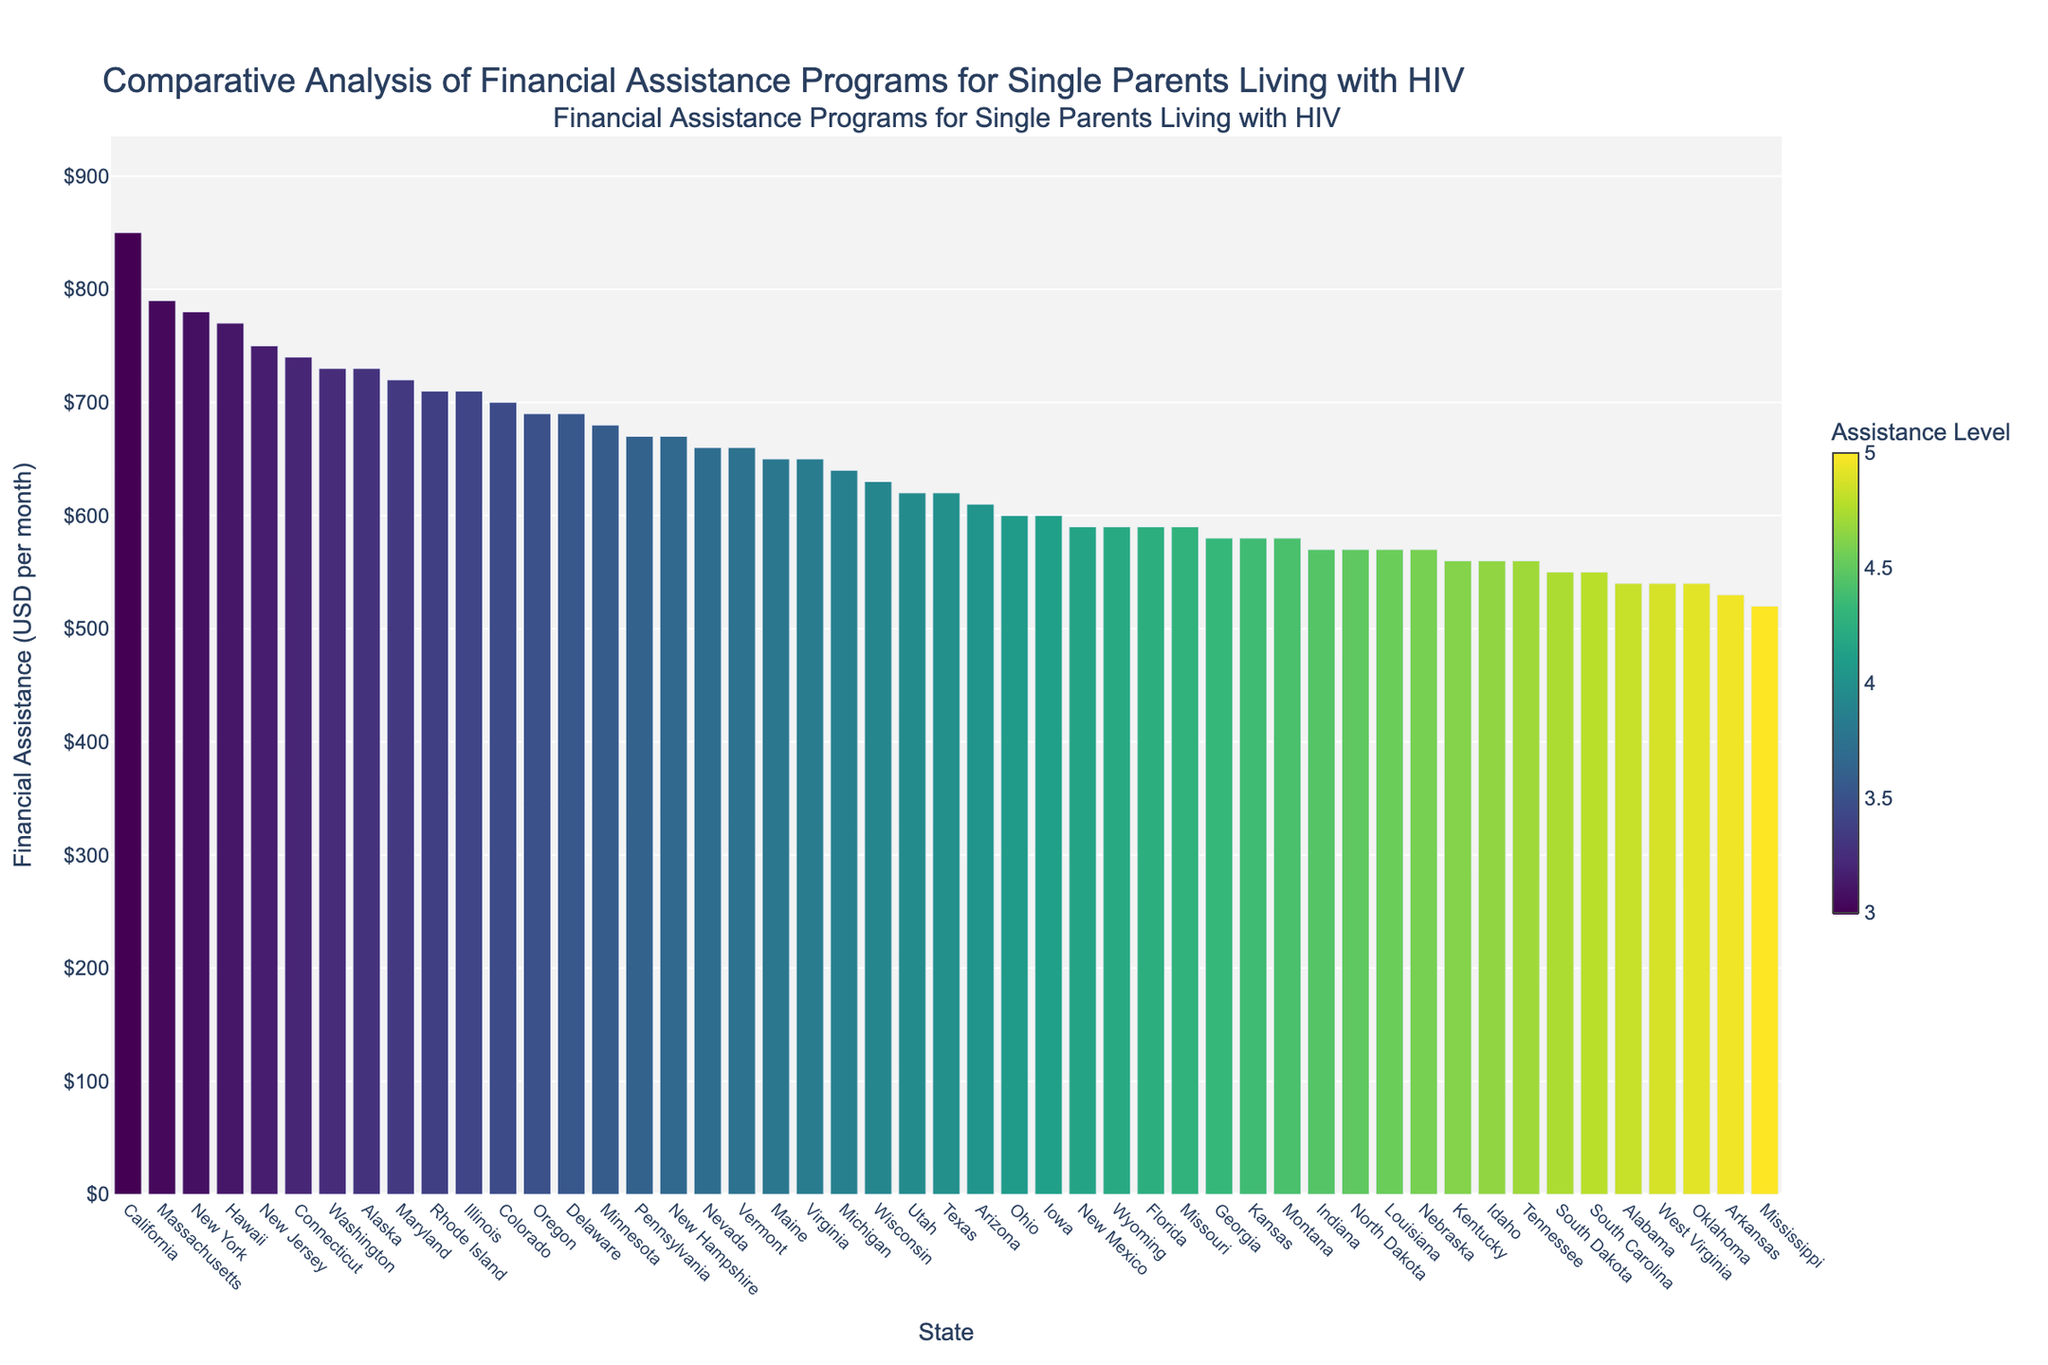What is the average financial assistance provided across all states? To calculate the average, sum the financial assistance amounts for all states and then divide by the number of states. Sum = 24840, Number of states = 50, Average = 24840 / 50 = 496.8
Answer: 496.8 Which state provides the highest financial assistance? The state with the highest bar represents the highest financial assistance. In the sorted chart, California is at the top with $850 per month.
Answer: California Which state provides the lowest financial assistance? The state with the shortest bar represents the lowest financial assistance. In the sorted chart, Mississippi is at the bottom with $520 per month.
Answer: Mississippi What is the total financial assistance provided by California and Massachusetts combined? Sum the financial assistance of California ($850) and Massachusetts ($790). Total = 850 + 790 = 1640
Answer: 1640 Is New York closer to the highest or lowest financial assistance value? Compare New York's financial assistance ($780) to the highest ($850) and lowest ($520). Difference to highest = 70, Difference to lowest = 260. New York is closer to the highest.
Answer: Highest Does the average financial assistance fall within the range provided by New Jersey? The range for New Jersey is its financial assistance, which is $750. Average assistance calculated earlier is 650, so it does fall within the range.
Answer: Yes How many states provide more than $700 in financial assistance? Count the number of states with bars higher than $700. These states are: California, New York, Illinois, New Jersey, Massachusetts, Washington, Maryland, Colorado, Connecticut, Hawaii. Total count = 10
Answer: 10 Which states provide exactly $590 in financial assistance? Identify the states with bars indicating $590. These states are Florida, Missouri, New Mexico, and Wyoming.
Answer: Florida, Missouri, New Mexico, Wyoming How much more financial assistance does California provide compared to Texas? Subtract Texas's financial assistance ($620) from California's ($850). Difference = 850 - 620 = 230
Answer: 230 What is the median financial assistance value? To find the median, sort the values and find the middle one. Since there are 50 states, the median is the average of the 25th and 26th values when sorted. These values are $600 and $600. Median = (600 + 600) / 2 = 600
Answer: 600 